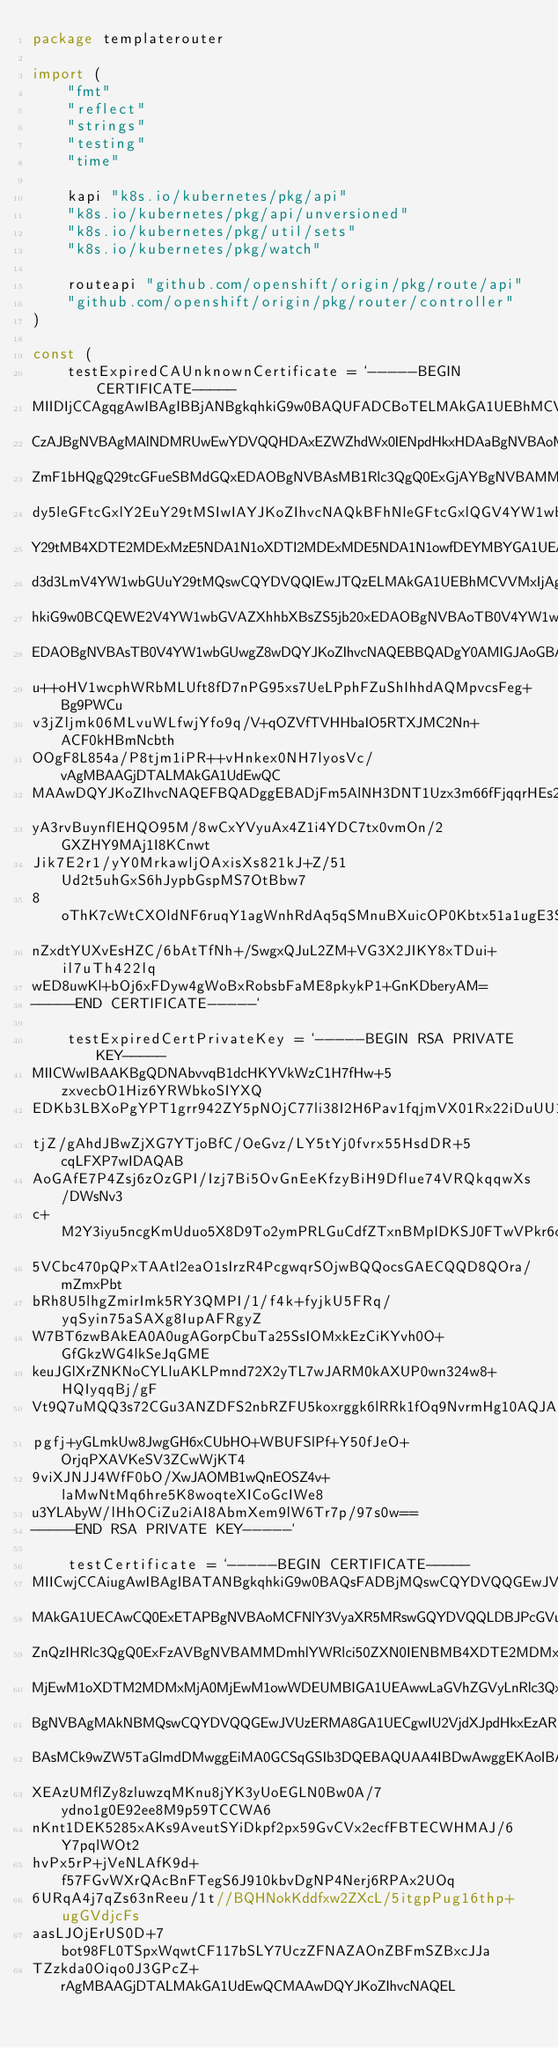<code> <loc_0><loc_0><loc_500><loc_500><_Go_>package templaterouter

import (
	"fmt"
	"reflect"
	"strings"
	"testing"
	"time"

	kapi "k8s.io/kubernetes/pkg/api"
	"k8s.io/kubernetes/pkg/api/unversioned"
	"k8s.io/kubernetes/pkg/util/sets"
	"k8s.io/kubernetes/pkg/watch"

	routeapi "github.com/openshift/origin/pkg/route/api"
	"github.com/openshift/origin/pkg/router/controller"
)

const (
	testExpiredCAUnknownCertificate = `-----BEGIN CERTIFICATE-----
MIIDIjCCAgqgAwIBAgIBBjANBgkqhkiG9w0BAQUFADCBoTELMAkGA1UEBhMCVVMx
CzAJBgNVBAgMAlNDMRUwEwYDVQQHDAxEZWZhdWx0IENpdHkxHDAaBgNVBAoME0Rl
ZmF1bHQgQ29tcGFueSBMdGQxEDAOBgNVBAsMB1Rlc3QgQ0ExGjAYBgNVBAMMEXd3
dy5leGFtcGxlY2EuY29tMSIwIAYJKoZIhvcNAQkBFhNleGFtcGxlQGV4YW1wbGUu
Y29tMB4XDTE2MDExMzE5NDA1N1oXDTI2MDExMDE5NDA1N1owfDEYMBYGA1UEAxMP
d3d3LmV4YW1wbGUuY29tMQswCQYDVQQIEwJTQzELMAkGA1UEBhMCVVMxIjAgBgkq
hkiG9w0BCQEWE2V4YW1wbGVAZXhhbXBsZS5jb20xEDAOBgNVBAoTB0V4YW1wbGUx
EDAOBgNVBAsTB0V4YW1wbGUwgZ8wDQYJKoZIhvcNAQEBBQADgY0AMIGJAoGBAM0B
u++oHV1wcphWRbMLUft8fD7nPG95xs7UeLPphFZuShIhhdAQMpvcsFeg+Bg9PWCu
v3jZljmk06MLvuWLfwjYfo9q/V+qOZVfTVHHbaIO5RTXJMC2Nn+ACF0kHBmNcbth
OOgF8L854a/P8tjm1iPR++vHnkex0NH7lyosVc/vAgMBAAGjDTALMAkGA1UdEwQC
MAAwDQYJKoZIhvcNAQEFBQADggEBADjFm5AlNH3DNT1Uzx3m66fFjqqrHEs25geT
yA3rvBuynflEHQO95M/8wCxYVyuAx4Z1i4YDC7tx0vmOn/2GXZHY9MAj1I8KCnwt
Jik7E2r1/yY0MrkawljOAxisXs821kJ+Z/51Ud2t5uhGxS6hJypbGspMS7OtBbw7
8oThK7cWtCXOldNF6ruqY1agWnhRdAq5qSMnuBXuicOP0Kbtx51a1ugE3SnvQenJ
nZxdtYUXvEsHZC/6bAtTfNh+/SwgxQJuL2ZM+VG3X2JIKY8xTDui+il7uTh422lq
wED8uwKl+bOj6xFDyw4gWoBxRobsbFaME8pkykP1+GnKDberyAM=
-----END CERTIFICATE-----`

	testExpiredCertPrivateKey = `-----BEGIN RSA PRIVATE KEY-----
MIICWwIBAAKBgQDNAbvvqB1dcHKYVkWzC1H7fHw+5zxvecbO1Hiz6YRWbkoSIYXQ
EDKb3LBXoPgYPT1grr942ZY5pNOjC77li38I2H6Pav1fqjmVX01Rx22iDuUU1yTA
tjZ/gAhdJBwZjXG7YTjoBfC/OeGvz/LY5tYj0fvrx55HsdDR+5cqLFXP7wIDAQAB
AoGAfE7P4Zsj6zOzGPI/Izj7Bi5OvGnEeKfzyBiH9Dflue74VRQkqqwXs/DWsNv3
c+M2Y3iyu5ncgKmUduo5X8D9To2ymPRLGuCdfZTxnBMpIDKSJ0FTwVPkr6cYyyBk
5VCbc470pQPxTAAtl2eaO1sIrzR4PcgwqrSOjwBQQocsGAECQQD8QOra/mZmxPbt
bRh8U5lhgZmirImk5RY3QMPI/1/f4k+fyjkU5FRq/yqSyin75aSAXg8IupAFRgyZ
W7BT6zwBAkEA0A0ugAGorpCbuTa25SsIOMxkEzCiKYvh0O+GfGkzWG4lkSeJqGME
keuJGlXrZNKNoCYLluAKLPmnd72X2yTL7wJARM0kAXUP0wn324w8+HQIyqqBj/gF
Vt9Q7uMQQ3s72CGu3ANZDFS2nbRZFU5koxrggk6lRRk1fOq9NvrmHg10AQJABOea
pgfj+yGLmkUw8JwgGH6xCUbHO+WBUFSlPf+Y50fJeO+OrjqPXAVKeSV3ZCwWjKT4
9viXJNJJ4WfF0bO/XwJAOMB1wQnEOSZ4v+laMwNtMq6hre5K8woqteXICoGcIWe8
u3YLAbyW/lHhOCiZu2iAI8AbmXem9lW6Tr7p/97s0w==
-----END RSA PRIVATE KEY-----`

	testCertificate = `-----BEGIN CERTIFICATE-----
MIICwjCCAiugAwIBAgIBATANBgkqhkiG9w0BAQsFADBjMQswCQYDVQQGEwJVUzEL
MAkGA1UECAwCQ0ExETAPBgNVBAoMCFNlY3VyaXR5MRswGQYDVQQLDBJPcGVuU2hp
ZnQzIHRlc3QgQ0ExFzAVBgNVBAMMDmhlYWRlci50ZXN0IENBMB4XDTE2MDMxMjA0
MjEwM1oXDTM2MDMxMjA0MjEwM1owWDEUMBIGA1UEAwwLaGVhZGVyLnRlc3QxCzAJ
BgNVBAgMAkNBMQswCQYDVQQGEwJVUzERMA8GA1UECgwIU2VjdXJpdHkxEzARBgNV
BAsMCk9wZW5TaGlmdDMwggEiMA0GCSqGSIb3DQEBAQUAA4IBDwAwggEKAoIBAQD0
XEAzUMflZy8zluwzqMKnu8jYK3yUoEGLN0Bw0A/7ydno1g0E92ee8M9p59TCCWA6
nKnt1DEK5285xAKs9AveutSYiDkpf2px59GvCVx2ecfFBTECWHMAJ/6Y7pqlWOt2
hvPx5rP+jVeNLAfK9d+f57FGvWXrQAcBnFTegS6J910kbvDgNP4Nerj6RPAx2UOq
6URqA4j7qZs63nReeu/1t//BQHNokKddfxw2ZXcL/5itgpPug16thp+ugGVdjcFs
aasLJOjErUS0D+7bot98FL0TSpxWqwtCF117bSLY7UczZFNAZAOnZBFmSZBxcJJa
TZzkda0Oiqo0J3GPcZ+rAgMBAAGjDTALMAkGA1UdEwQCMAAwDQYJKoZIhvcNAQEL</code> 